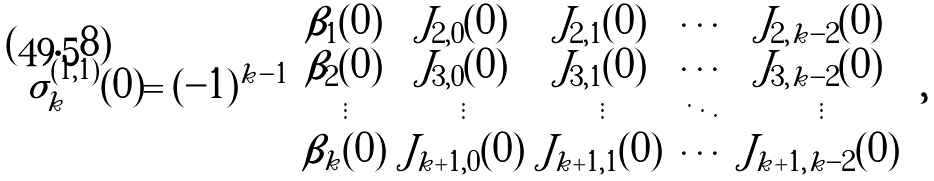Convert formula to latex. <formula><loc_0><loc_0><loc_500><loc_500>\sigma _ { k } ^ { ( 1 , 1 ) } ( 0 ) = ( - 1 ) ^ { k - 1 } \left | \begin{array} { c c c c c } \beta _ { 1 } ( 0 ) & J _ { 2 , 0 } ( 0 ) & J _ { 2 , 1 } ( 0 ) & \cdots & J _ { 2 , k - 2 } ( 0 ) \\ \beta _ { 2 } ( 0 ) & J _ { 3 , 0 } ( 0 ) & J _ { 3 , 1 } ( 0 ) & \cdots & J _ { 3 , k - 2 } ( 0 ) \\ \vdots & \vdots & \vdots & \ddots & \vdots \\ \beta _ { k } ( 0 ) & J _ { k + 1 , 0 } ( 0 ) & J _ { k + 1 , 1 } ( 0 ) & \cdots & J _ { k + 1 , k - 2 } ( 0 ) \end{array} \right | ,</formula> 